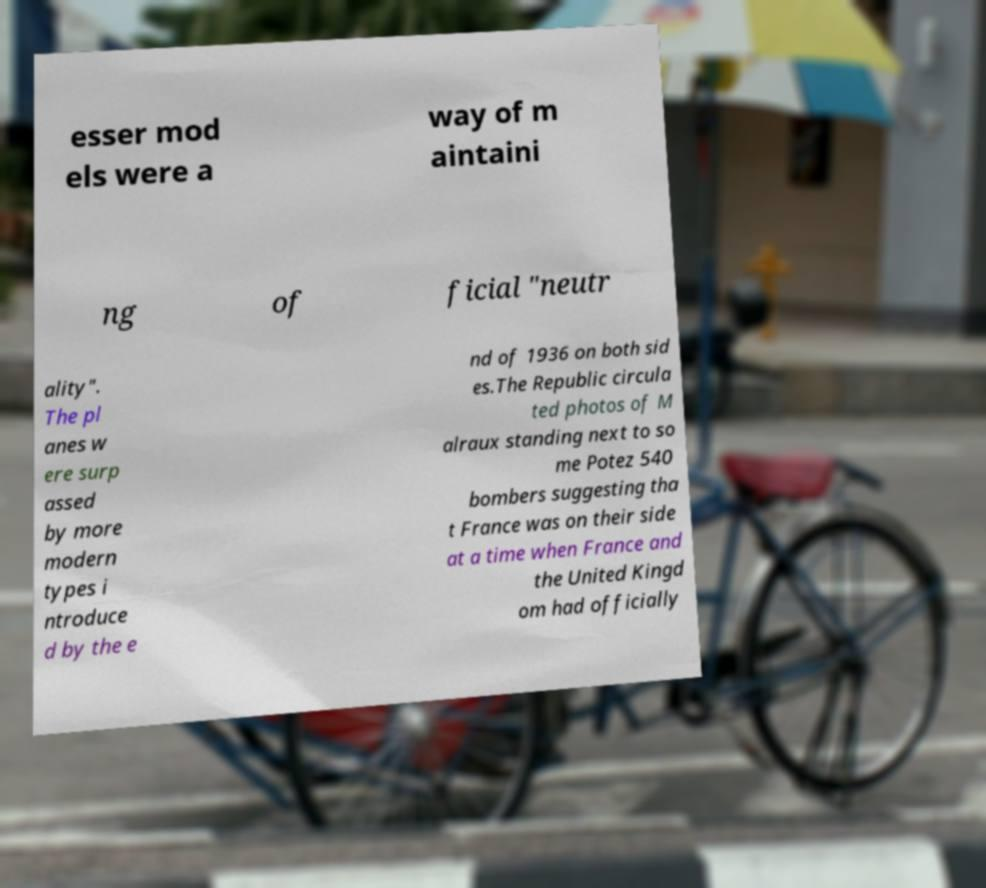Could you assist in decoding the text presented in this image and type it out clearly? esser mod els were a way of m aintaini ng of ficial "neutr ality". The pl anes w ere surp assed by more modern types i ntroduce d by the e nd of 1936 on both sid es.The Republic circula ted photos of M alraux standing next to so me Potez 540 bombers suggesting tha t France was on their side at a time when France and the United Kingd om had officially 